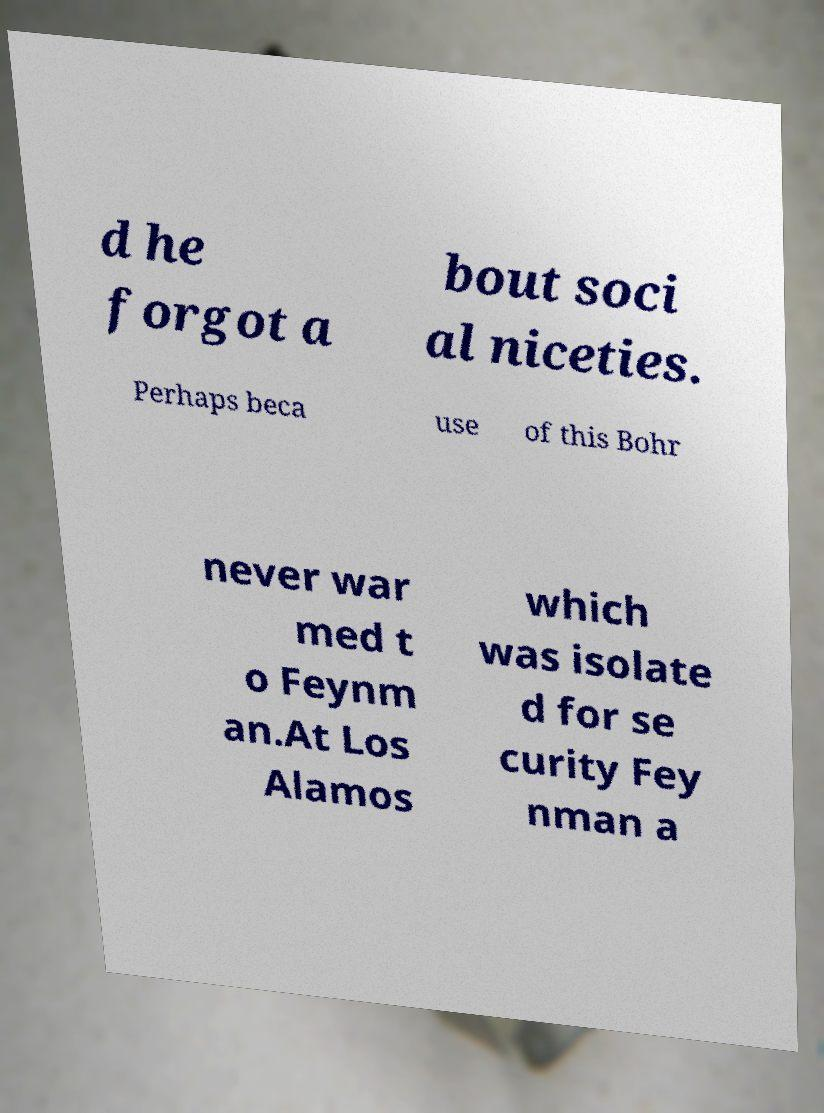I need the written content from this picture converted into text. Can you do that? d he forgot a bout soci al niceties. Perhaps beca use of this Bohr never war med t o Feynm an.At Los Alamos which was isolate d for se curity Fey nman a 